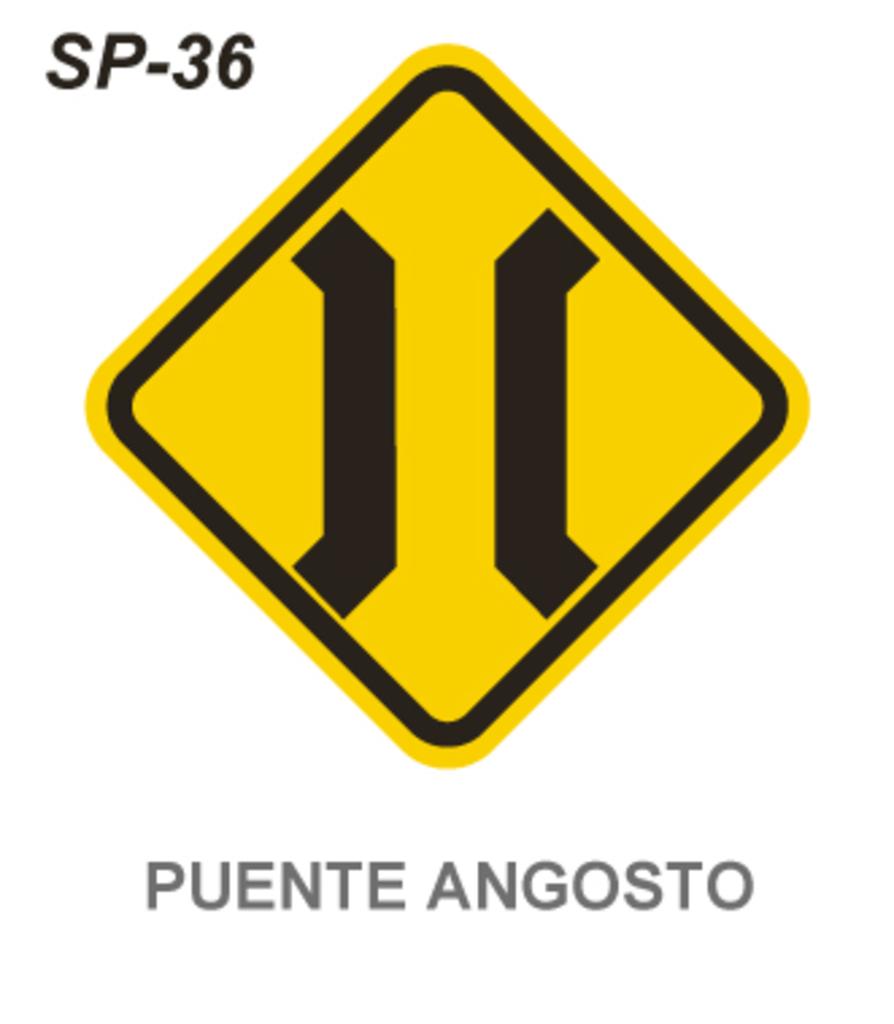What number is after sp?
Your answer should be very brief. 36. What letters are before 36?
Ensure brevity in your answer.  Sp. 